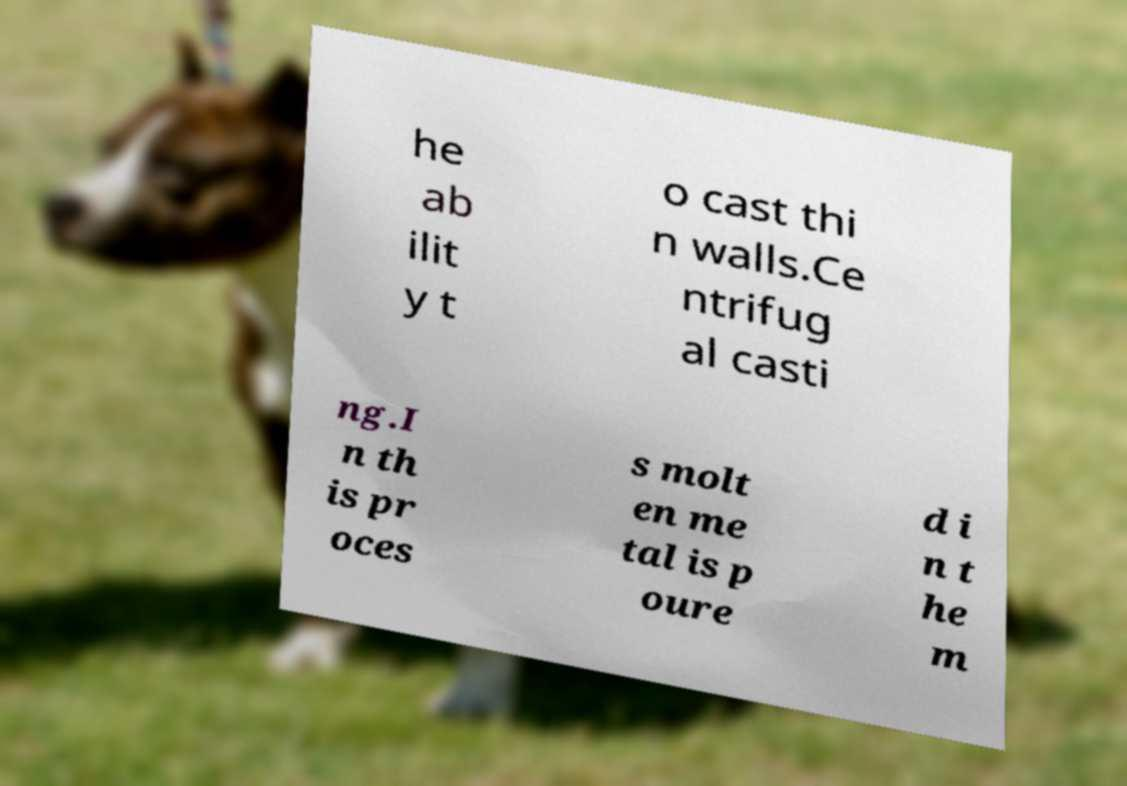Could you assist in decoding the text presented in this image and type it out clearly? he ab ilit y t o cast thi n walls.Ce ntrifug al casti ng.I n th is pr oces s molt en me tal is p oure d i n t he m 